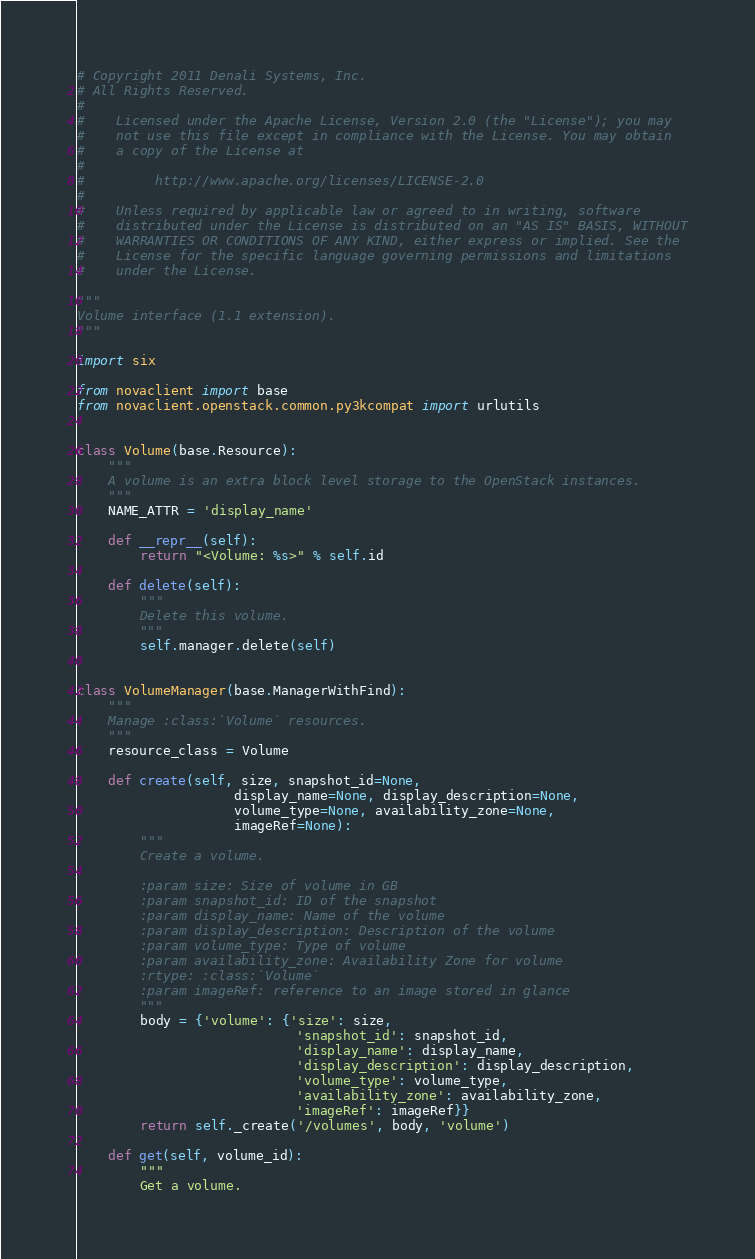Convert code to text. <code><loc_0><loc_0><loc_500><loc_500><_Python_># Copyright 2011 Denali Systems, Inc.
# All Rights Reserved.
#
#    Licensed under the Apache License, Version 2.0 (the "License"); you may
#    not use this file except in compliance with the License. You may obtain
#    a copy of the License at
#
#         http://www.apache.org/licenses/LICENSE-2.0
#
#    Unless required by applicable law or agreed to in writing, software
#    distributed under the License is distributed on an "AS IS" BASIS, WITHOUT
#    WARRANTIES OR CONDITIONS OF ANY KIND, either express or implied. See the
#    License for the specific language governing permissions and limitations
#    under the License.

"""
Volume interface (1.1 extension).
"""

import six

from novaclient import base
from novaclient.openstack.common.py3kcompat import urlutils


class Volume(base.Resource):
    """
    A volume is an extra block level storage to the OpenStack instances.
    """
    NAME_ATTR = 'display_name'

    def __repr__(self):
        return "<Volume: %s>" % self.id

    def delete(self):
        """
        Delete this volume.
        """
        self.manager.delete(self)


class VolumeManager(base.ManagerWithFind):
    """
    Manage :class:`Volume` resources.
    """
    resource_class = Volume

    def create(self, size, snapshot_id=None,
                    display_name=None, display_description=None,
                    volume_type=None, availability_zone=None,
                    imageRef=None):
        """
        Create a volume.

        :param size: Size of volume in GB
        :param snapshot_id: ID of the snapshot
        :param display_name: Name of the volume
        :param display_description: Description of the volume
        :param volume_type: Type of volume
        :param availability_zone: Availability Zone for volume
        :rtype: :class:`Volume`
        :param imageRef: reference to an image stored in glance
        """
        body = {'volume': {'size': size,
                            'snapshot_id': snapshot_id,
                            'display_name': display_name,
                            'display_description': display_description,
                            'volume_type': volume_type,
                            'availability_zone': availability_zone,
                            'imageRef': imageRef}}
        return self._create('/volumes', body, 'volume')

    def get(self, volume_id):
        """
        Get a volume.
</code> 